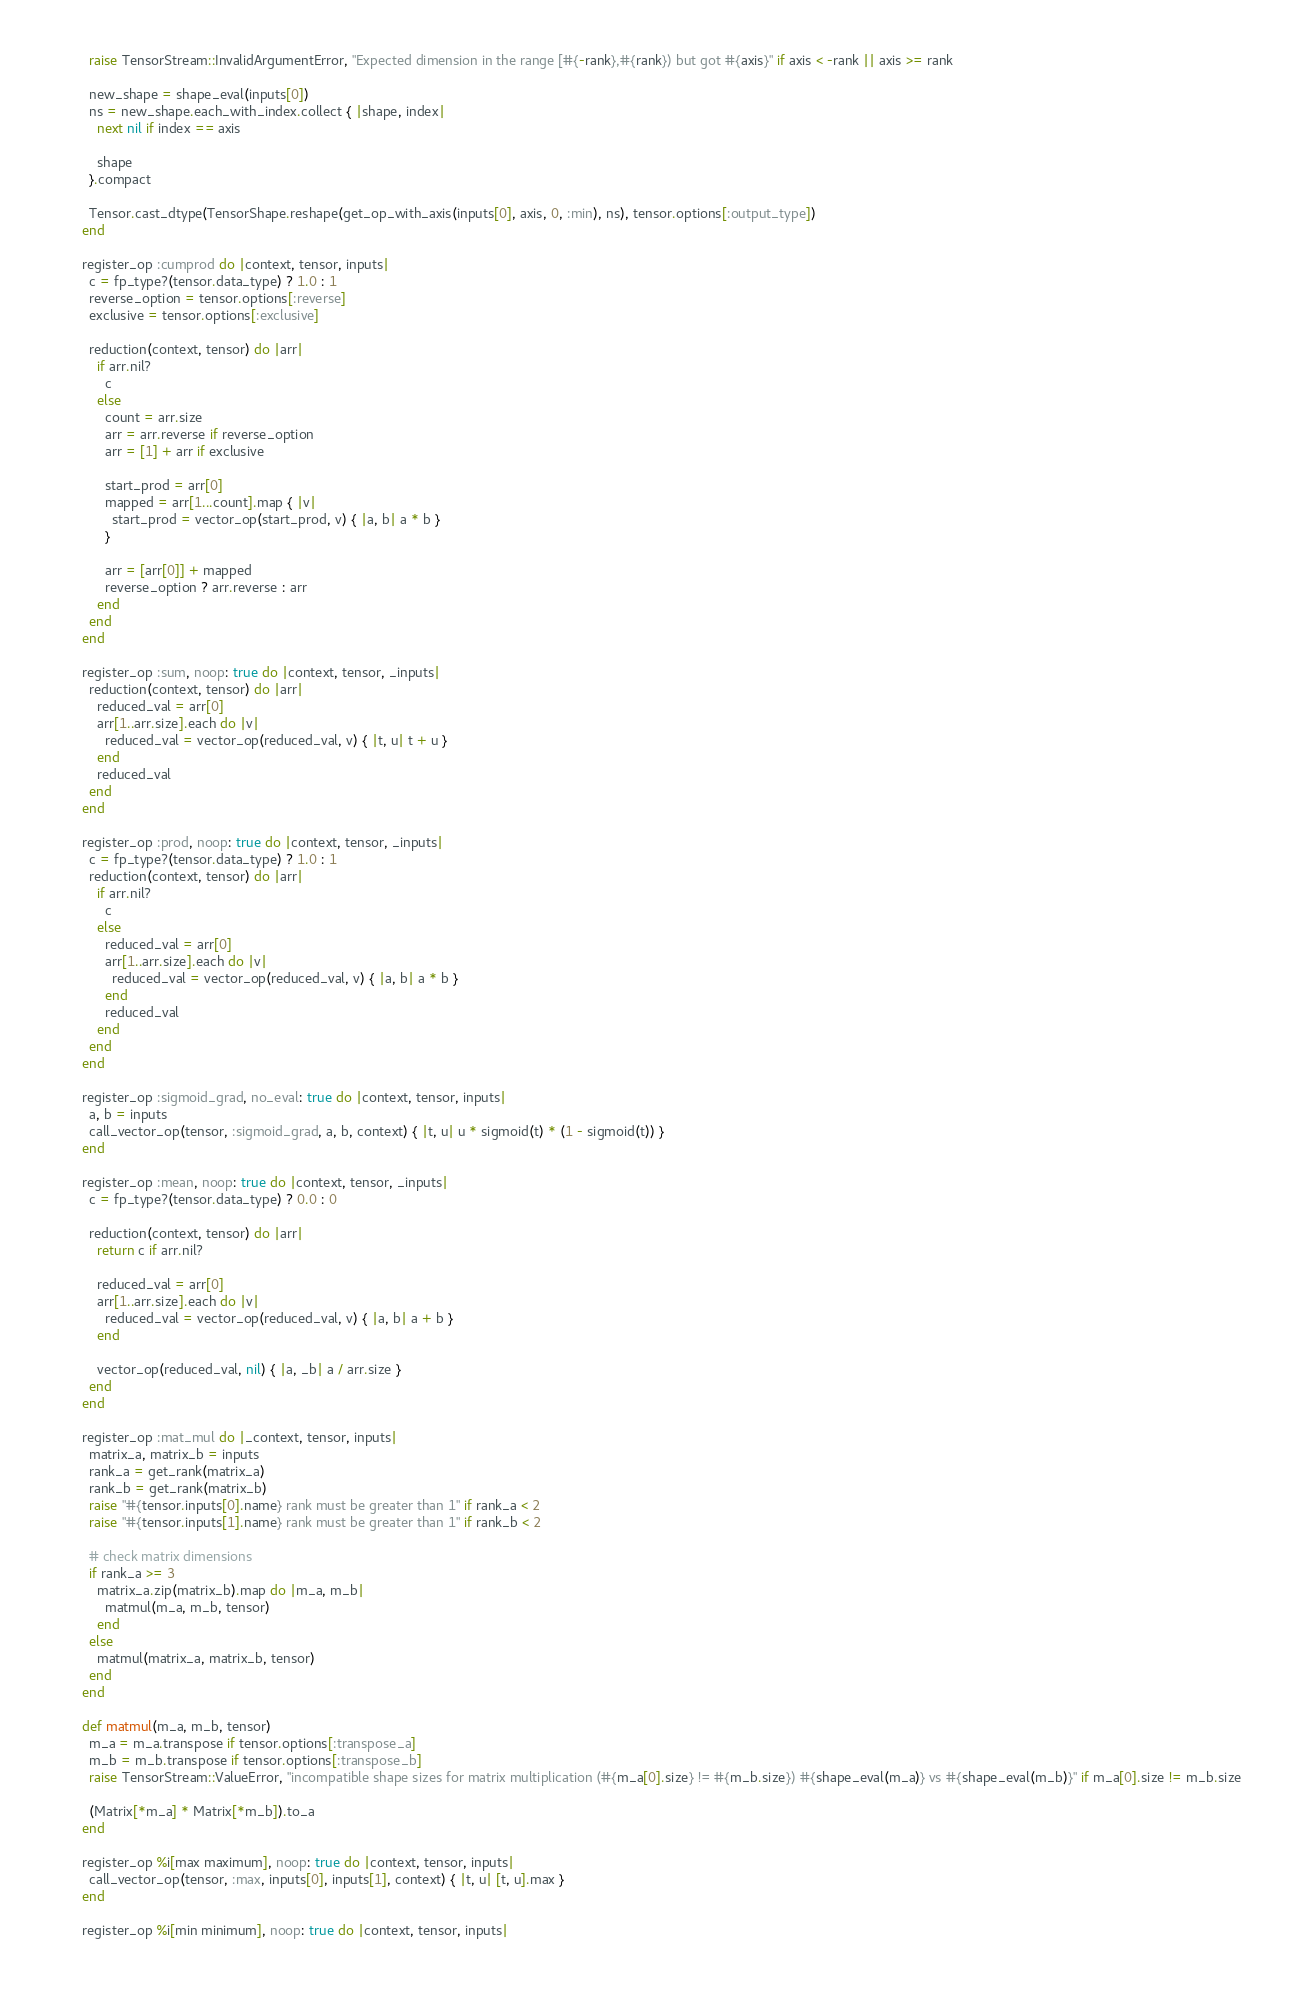<code> <loc_0><loc_0><loc_500><loc_500><_Ruby_>          raise TensorStream::InvalidArgumentError, "Expected dimension in the range [#{-rank},#{rank}) but got #{axis}" if axis < -rank || axis >= rank

          new_shape = shape_eval(inputs[0])
          ns = new_shape.each_with_index.collect { |shape, index|
            next nil if index == axis

            shape
          }.compact

          Tensor.cast_dtype(TensorShape.reshape(get_op_with_axis(inputs[0], axis, 0, :min), ns), tensor.options[:output_type])
        end

        register_op :cumprod do |context, tensor, inputs|
          c = fp_type?(tensor.data_type) ? 1.0 : 1
          reverse_option = tensor.options[:reverse]
          exclusive = tensor.options[:exclusive]

          reduction(context, tensor) do |arr|
            if arr.nil?
              c
            else
              count = arr.size
              arr = arr.reverse if reverse_option
              arr = [1] + arr if exclusive

              start_prod = arr[0]
              mapped = arr[1...count].map { |v|
                start_prod = vector_op(start_prod, v) { |a, b| a * b }
              }

              arr = [arr[0]] + mapped
              reverse_option ? arr.reverse : arr
            end
          end
        end

        register_op :sum, noop: true do |context, tensor, _inputs|
          reduction(context, tensor) do |arr|
            reduced_val = arr[0]
            arr[1..arr.size].each do |v|
              reduced_val = vector_op(reduced_val, v) { |t, u| t + u }
            end
            reduced_val
          end
        end

        register_op :prod, noop: true do |context, tensor, _inputs|
          c = fp_type?(tensor.data_type) ? 1.0 : 1
          reduction(context, tensor) do |arr|
            if arr.nil?
              c
            else
              reduced_val = arr[0]
              arr[1..arr.size].each do |v|
                reduced_val = vector_op(reduced_val, v) { |a, b| a * b }
              end
              reduced_val
            end
          end
        end

        register_op :sigmoid_grad, no_eval: true do |context, tensor, inputs|
          a, b = inputs
          call_vector_op(tensor, :sigmoid_grad, a, b, context) { |t, u| u * sigmoid(t) * (1 - sigmoid(t)) }
        end

        register_op :mean, noop: true do |context, tensor, _inputs|
          c = fp_type?(tensor.data_type) ? 0.0 : 0

          reduction(context, tensor) do |arr|
            return c if arr.nil?

            reduced_val = arr[0]
            arr[1..arr.size].each do |v|
              reduced_val = vector_op(reduced_val, v) { |a, b| a + b }
            end

            vector_op(reduced_val, nil) { |a, _b| a / arr.size }
          end
        end

        register_op :mat_mul do |_context, tensor, inputs|
          matrix_a, matrix_b = inputs
          rank_a = get_rank(matrix_a)
          rank_b = get_rank(matrix_b)
          raise "#{tensor.inputs[0].name} rank must be greater than 1" if rank_a < 2
          raise "#{tensor.inputs[1].name} rank must be greater than 1" if rank_b < 2

          # check matrix dimensions
          if rank_a >= 3
            matrix_a.zip(matrix_b).map do |m_a, m_b|
              matmul(m_a, m_b, tensor)
            end
          else
            matmul(matrix_a, matrix_b, tensor)
          end
        end

        def matmul(m_a, m_b, tensor)
          m_a = m_a.transpose if tensor.options[:transpose_a]
          m_b = m_b.transpose if tensor.options[:transpose_b]
          raise TensorStream::ValueError, "incompatible shape sizes for matrix multiplication (#{m_a[0].size} != #{m_b.size}) #{shape_eval(m_a)} vs #{shape_eval(m_b)}" if m_a[0].size != m_b.size

          (Matrix[*m_a] * Matrix[*m_b]).to_a
        end

        register_op %i[max maximum], noop: true do |context, tensor, inputs|
          call_vector_op(tensor, :max, inputs[0], inputs[1], context) { |t, u| [t, u].max }
        end

        register_op %i[min minimum], noop: true do |context, tensor, inputs|</code> 